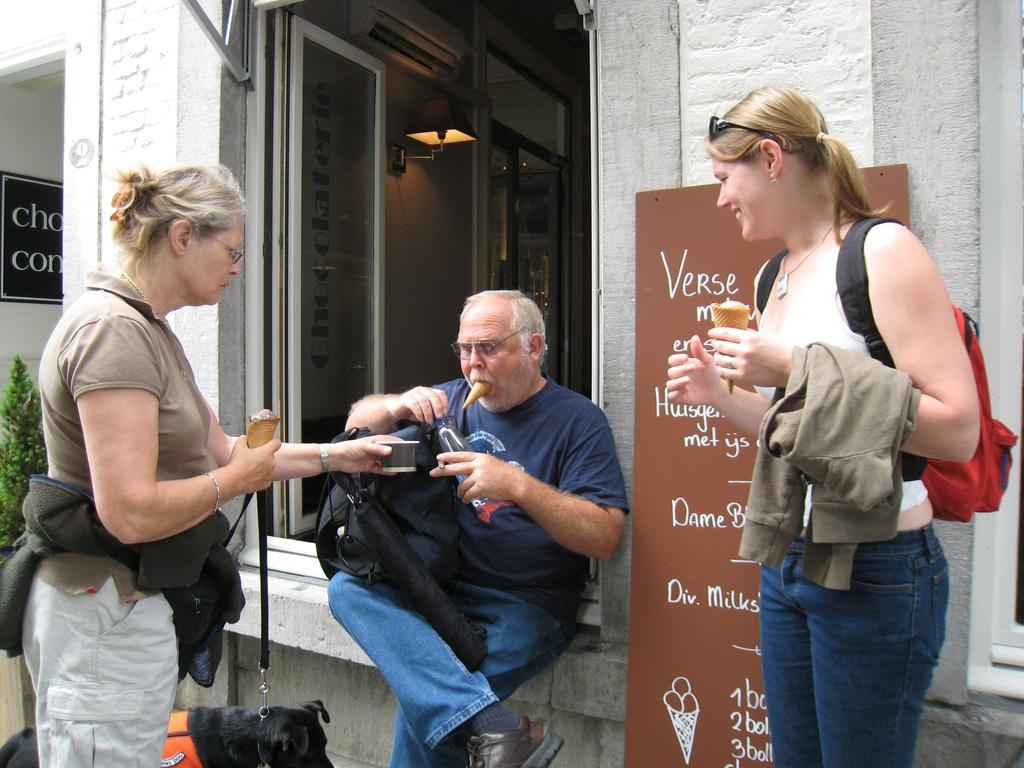What is the color of the wall in the image? The wall in the image is white. What can be seen on the wall in the image? There is a window on the wall in the image. How many people are present in the image? There are there? What type of vegetation is present in the image? There is a plant in the image. What type of cloth is being used to promote peace in the image? There is no cloth or reference to promoting peace in the image. 